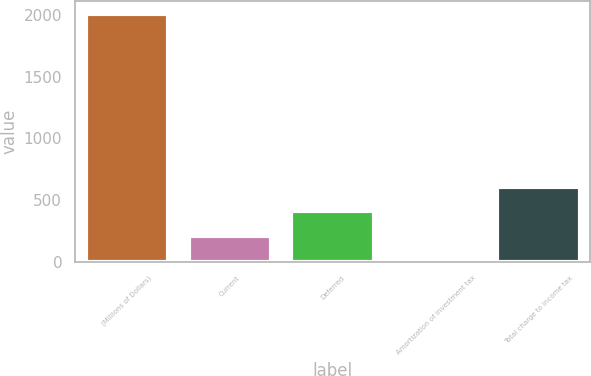Convert chart to OTSL. <chart><loc_0><loc_0><loc_500><loc_500><bar_chart><fcel>(Millions of Dollars)<fcel>Current<fcel>Deferred<fcel>Amortization of investment tax<fcel>Total charge to income tax<nl><fcel>2010<fcel>206.4<fcel>406.8<fcel>6<fcel>607.2<nl></chart> 